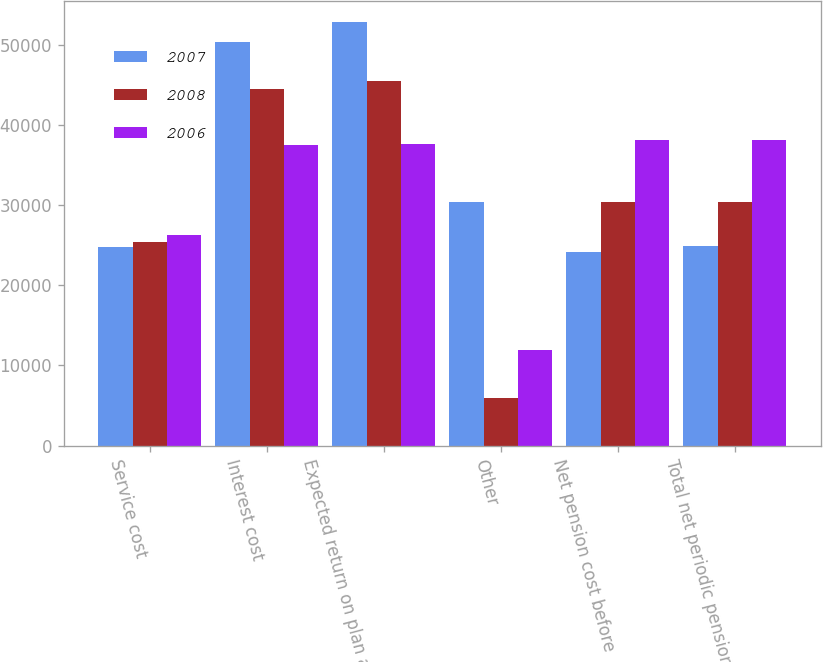Convert chart to OTSL. <chart><loc_0><loc_0><loc_500><loc_500><stacked_bar_chart><ecel><fcel>Service cost<fcel>Interest cost<fcel>Expected return on plan assets<fcel>Other<fcel>Net pension cost before<fcel>Total net periodic pension<nl><fcel>2007<fcel>24763<fcel>50421<fcel>52884<fcel>30345<fcel>24120<fcel>24874<nl><fcel>2008<fcel>25366<fcel>44486<fcel>45481<fcel>5974<fcel>30345<fcel>30345<nl><fcel>2006<fcel>26313<fcel>37510<fcel>37577<fcel>11896<fcel>38142<fcel>38142<nl></chart> 